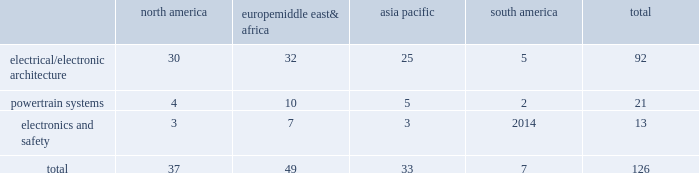Table of contents item 1b .
Unresolved staff comments we have no unresolved sec staff comments to report .
Item 2 .
Properties as of december 31 , 2015 , we owned or leased 126 major manufacturing sites and 14 major technical centers .
A manufacturing site may include multiple plants and may be wholly or partially owned or leased .
We also have many smaller manufacturing sites , sales offices , warehouses , engineering centers , joint ventures and other investments strategically located throughout the world .
We have a presence in 44 countries .
The table shows the regional distribution of our major manufacturing sites by the operating segment that uses such facilities : north america europe , middle east & africa asia pacific south america total .
In addition to these manufacturing sites , we had 14 major technical centers : four in north america ; five in europe , middle east and africa ; four in asia pacific ; and one in south america .
Of our 126 major manufacturing sites and 14 major technical centers , which include facilities owned or leased by our consolidated subsidiaries , 77 are primarily owned and 63 are primarily leased .
We frequently review our real estate portfolio and develop footprint strategies to support our customers 2019 global plans , while at the same time supporting our technical needs and controlling operating expenses .
We believe our evolving portfolio will meet current and anticipated future needs .
Item 3 .
Legal proceedings we are from time to time subject to various actions , claims , suits , government investigations , and other proceedings incidental to our business , including those arising out of alleged defects , breach of contracts , competition and antitrust matters , product warranties , intellectual property matters , personal injury claims and employment-related matters .
It is our opinion that the outcome of such matters will not have a material adverse impact on our consolidated financial position , results of operations , or cash flows .
With respect to warranty matters , although we cannot ensure that the future costs of warranty claims by customers will not be material , we believe our established reserves are adequate to cover potential warranty settlements .
However , the final amounts required to resolve these matters could differ materially from our recorded estimates .
Gm ignition switch recall in the first quarter of 2014 , gm , delphi 2019s largest customer , initiated a product recall related to ignition switches .
Delphi received requests for information from , and cooperated with , various government agencies related to this ignition switch recall .
In addition , delphi was initially named as a co-defendant along with gm ( and in certain cases other parties ) in class action and product liability lawsuits related to this matter .
As of december 31 , 2015 , delphi was not named as a defendant in any class action complaints .
Although no assurances can be made as to the ultimate outcome of these or any other future claims , delphi does not believe a loss is probable and , accordingly , no reserve has been made as of december 31 , 2015 .
Unsecured creditors litigation the fourth amended and restated limited liability partnership agreement of delphi automotive llp ( the 201cfourth llp agreement 201d ) was entered into on july 12 , 2011 by the members of delphi automotive llp in order to position the company for its initial public offering .
Under the terms of the fourth llp agreement , if cumulative distributions to the members of delphi automotive llp under certain provisions of the fourth llp agreement exceed $ 7.2 billion , delphi , as disbursing agent on behalf of dphh , is required to pay to the holders of allowed general unsecured claims against dphh $ 32.50 for every $ 67.50 in excess of $ 7.2 billion distributed to the members , up to a maximum amount of $ 300 million .
In december 2014 , a complaint was filed in the bankruptcy court alleging that the redemption by delphi automotive llp of the membership interests of gm and the pbgc , and the repurchase of shares and payment of dividends by delphi automotive plc , constituted distributions under the terms of the fourth llp agreement approximating $ 7.2 billion .
Delphi considers cumulative .
What percentage of major manufacturing sites are in europe middle east& africa? 
Computations: (49 / 126)
Answer: 0.38889. 